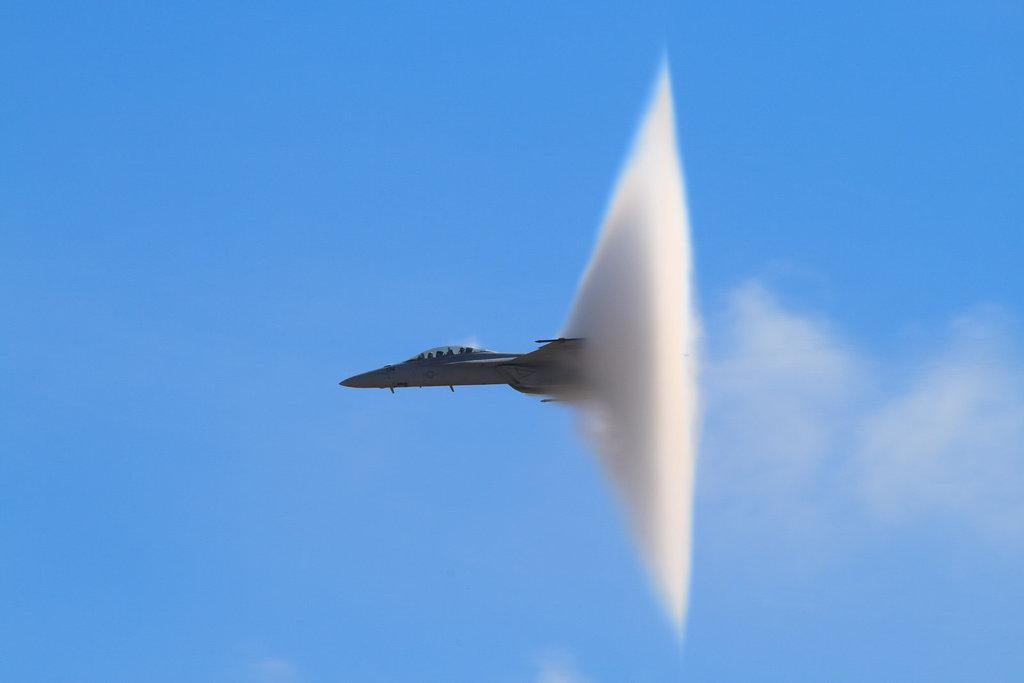What is the main subject of the image? The main subject of the image is a hornet jet. What is the hornet jet doing in the image? The jet is flying in the sky. What type of pancake is being served on the wing of the jet in the image? There is no pancake present on the wing of the jet in the image. Where is the nest of the hornet jet located in the image? There is no nest associated with the hornet jet in the image. Can you see any ghosts flying alongside the jet in the image? There are no ghosts present in the image. 